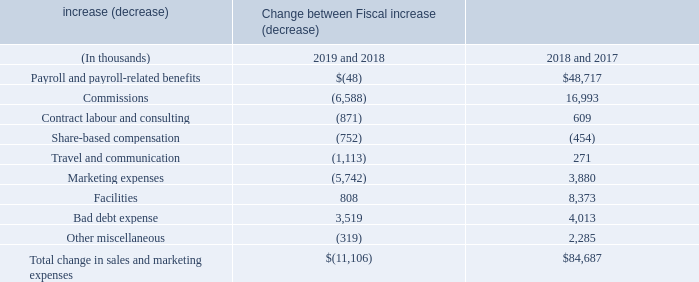Sales and marketing expenses consist primarily of personnel expenses and costs associated with advertising, marketing events and trade shows.
Sales and marketing expenses decreased by $11.1 million during the year ended June 30, 2019 as compared to the prior fiscal year. This was primarily due to (i) a decrease in commissions expense of $6.6 million, of which approximately $8.9 million is the net result of the Company capitalizing more commission expense under Topic 606, whereas previously, under Topic 605, such costs would have been expensed as incurred, (ii) a decrease in marketing expenses of $5.7 million and (iii) a decrease in travel and communication expenses of $1.1 million. These were partially offset by (i) an increase in bad debt expense of $3.5 million as certain low dollar receivables were provided for entirely as they became aged greater than one year. Overall, our sales and marketing expenses, as a percentage of total revenues, decreased to approximately 18% from approximately 19% in the prior fiscal year.
Our sales and marketing labour resources increased by 103 employees, from 1,948 employees at June 30, 2018 to 2,051 employees at June 30, 2019.
What does Sales and marketing expenses consist primarily of? Personnel expenses and costs associated with advertising, marketing events and trade shows. How many employees are there at June 30, 2019? 2,051. What is the Total decrease in sales and marketing expenses from 2018 to 2019?
Answer scale should be: thousand. 11,106. What is the Total change in sales and marketing expenses from fiscal year 2017 to 2019?
Answer scale should be: thousand. 84,687-11,106
Answer: 73581. What is the average annual Total change in sales and marketing expenses? 
Answer scale should be: thousand. (84,687-11,106)/2
Answer: 36790.5. What is the change in Marketing expenses from 2017 to 2019?
Answer scale should be: thousand. 3,880-5,742
Answer: -1862. 